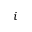<formula> <loc_0><loc_0><loc_500><loc_500>i</formula> 